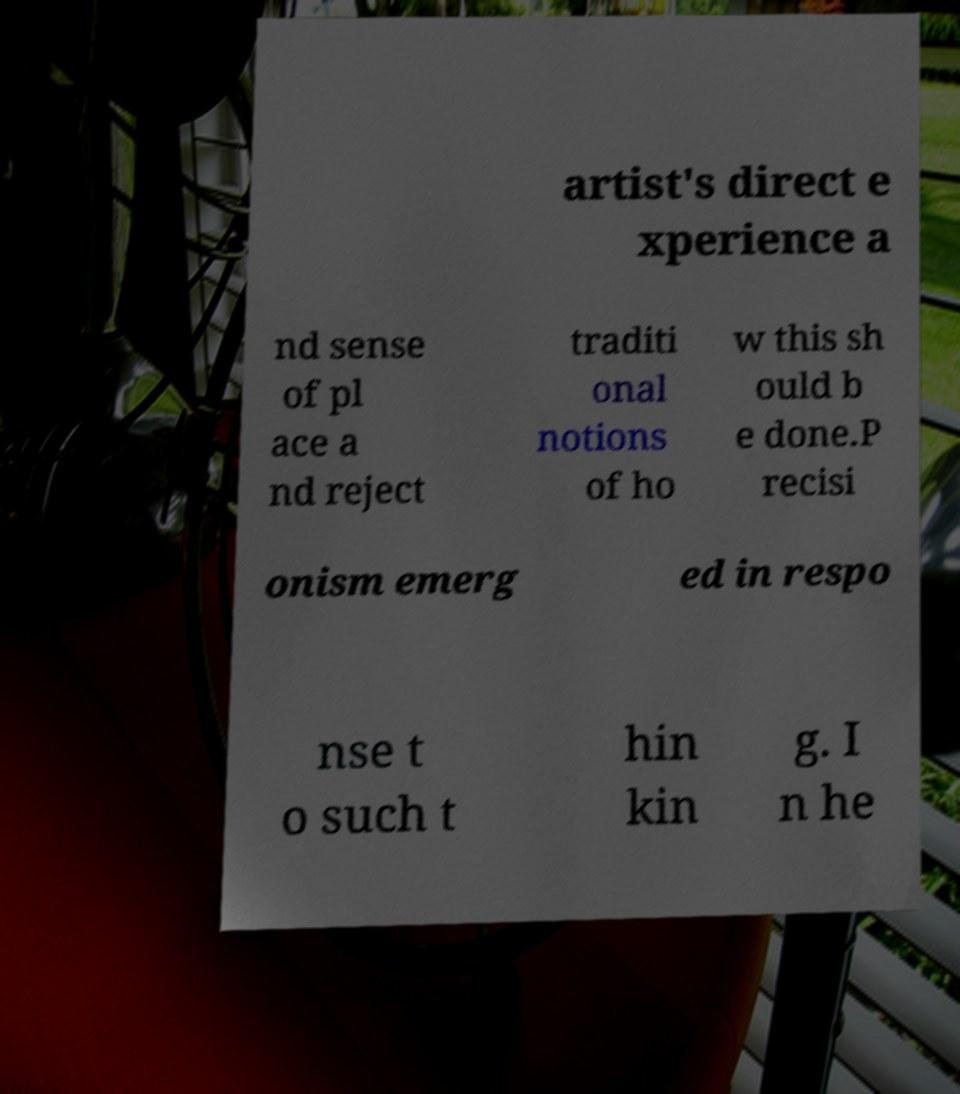There's text embedded in this image that I need extracted. Can you transcribe it verbatim? artist's direct e xperience a nd sense of pl ace a nd reject traditi onal notions of ho w this sh ould b e done.P recisi onism emerg ed in respo nse t o such t hin kin g. I n he 